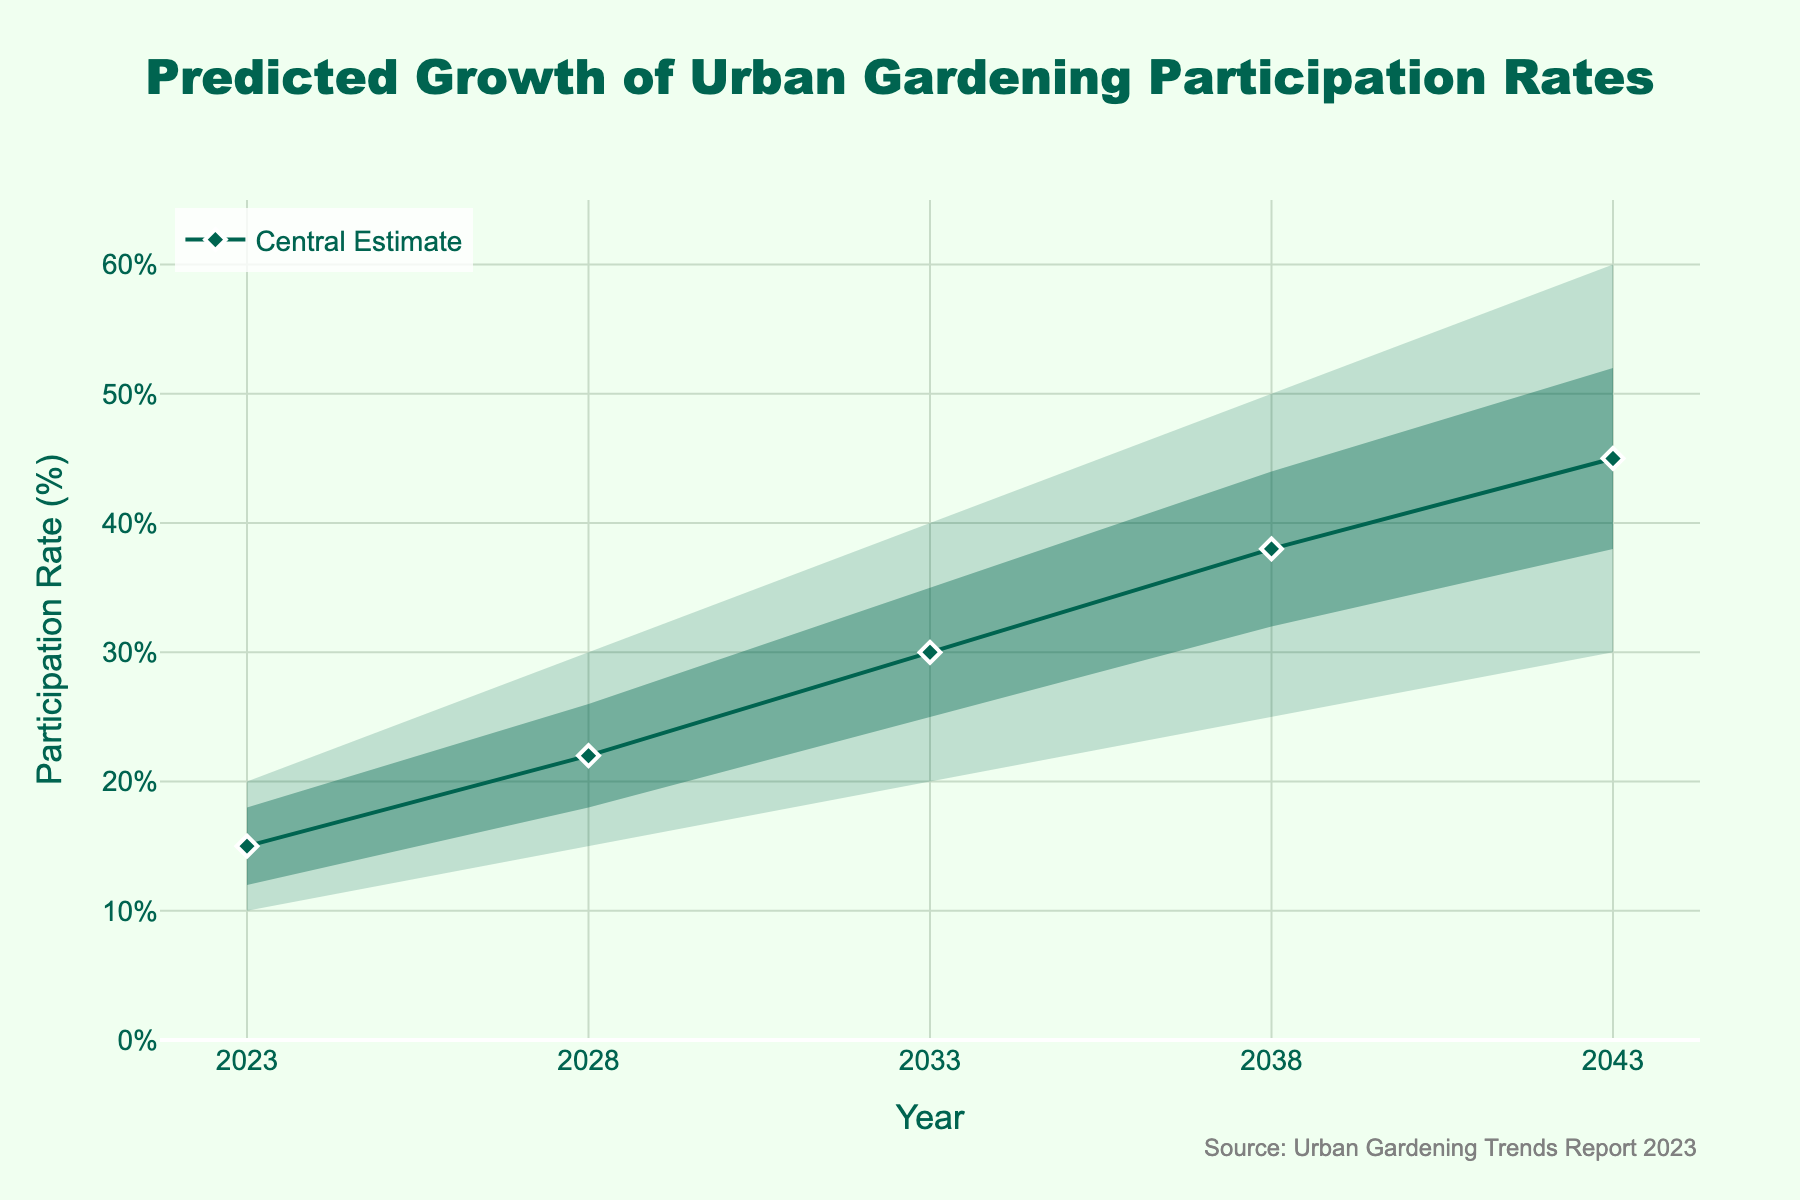what is the title of the figure? The title of the figure is displayed at the top and provides a summary of what the chart represents: "Predicted Growth of Urban Gardening Participation Rates".
Answer: Predicted Growth of Urban Gardening Participation Rates What is the central estimate of the participation rate in 2033? Locate the year 2033 along the x-axis, then find the corresponding value on the "Central Estimate" line, which is highlighted by a diamonds marker.
Answer: 30% What is the difference between the upper bound and lower bound estimates in 2043? Locate the year 2043 along the x-axis. The upper bound is 60% and the lower bound is 30%. Calculate the difference: 60 - 30.
Answer: 30% How does the central estimate in 2023 compare to that in 2028? Identify the values of the central estimate in both 2023 (15%) and 2028 (22%). Compare these values to see that the participation rate increases.
Answer: It increases Which year has the highest predicted central estimate of urban gardening participation? Identify the central estimates for each year along the chart. The highest value (45%) is in the year 2043.
Answer: 2043 What's the range of the predicted participation rates for the year 2038? Locate the year 2038 and find the lower (25%) and upper (50%) bounds. The range is calculated as upper bound - lower bound: 50 - 25.
Answer: 25% What trend do you notice in the central estimate over the 20-year period? Observe the central estimate values from 2023 to 2043 along the line. There's a consistent increase in the central estimates over time.
Answer: Increasing trend Is the uncertainty in the predictions growing or shrinking over time? Examine the width of the areas between the lower and upper bounds, as well as between the low and high estimates. The areas widen as time progresses, indicating growing uncertainty.
Answer: Growing Which year has the smallest difference between the high estimate and the central estimate? Compare the differences between the high estimate and the central estimate for each year. The smallest difference is in the earliest year, 2023 (18% - 15% = 3%).
Answer: 2023 What is the predicted high estimate of urban gardening participation rate in 2033? Locate the year 2033 along the x-axis and find the corresponding high estimate value, which is 35%.
Answer: 35% 